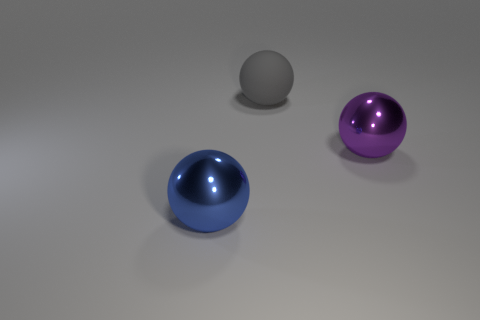Add 2 gray rubber spheres. How many objects exist? 5 Add 1 big blue metallic spheres. How many big blue metallic spheres exist? 2 Subtract 0 red blocks. How many objects are left? 3 Subtract all big purple metallic things. Subtract all big green balls. How many objects are left? 2 Add 2 big gray objects. How many big gray objects are left? 3 